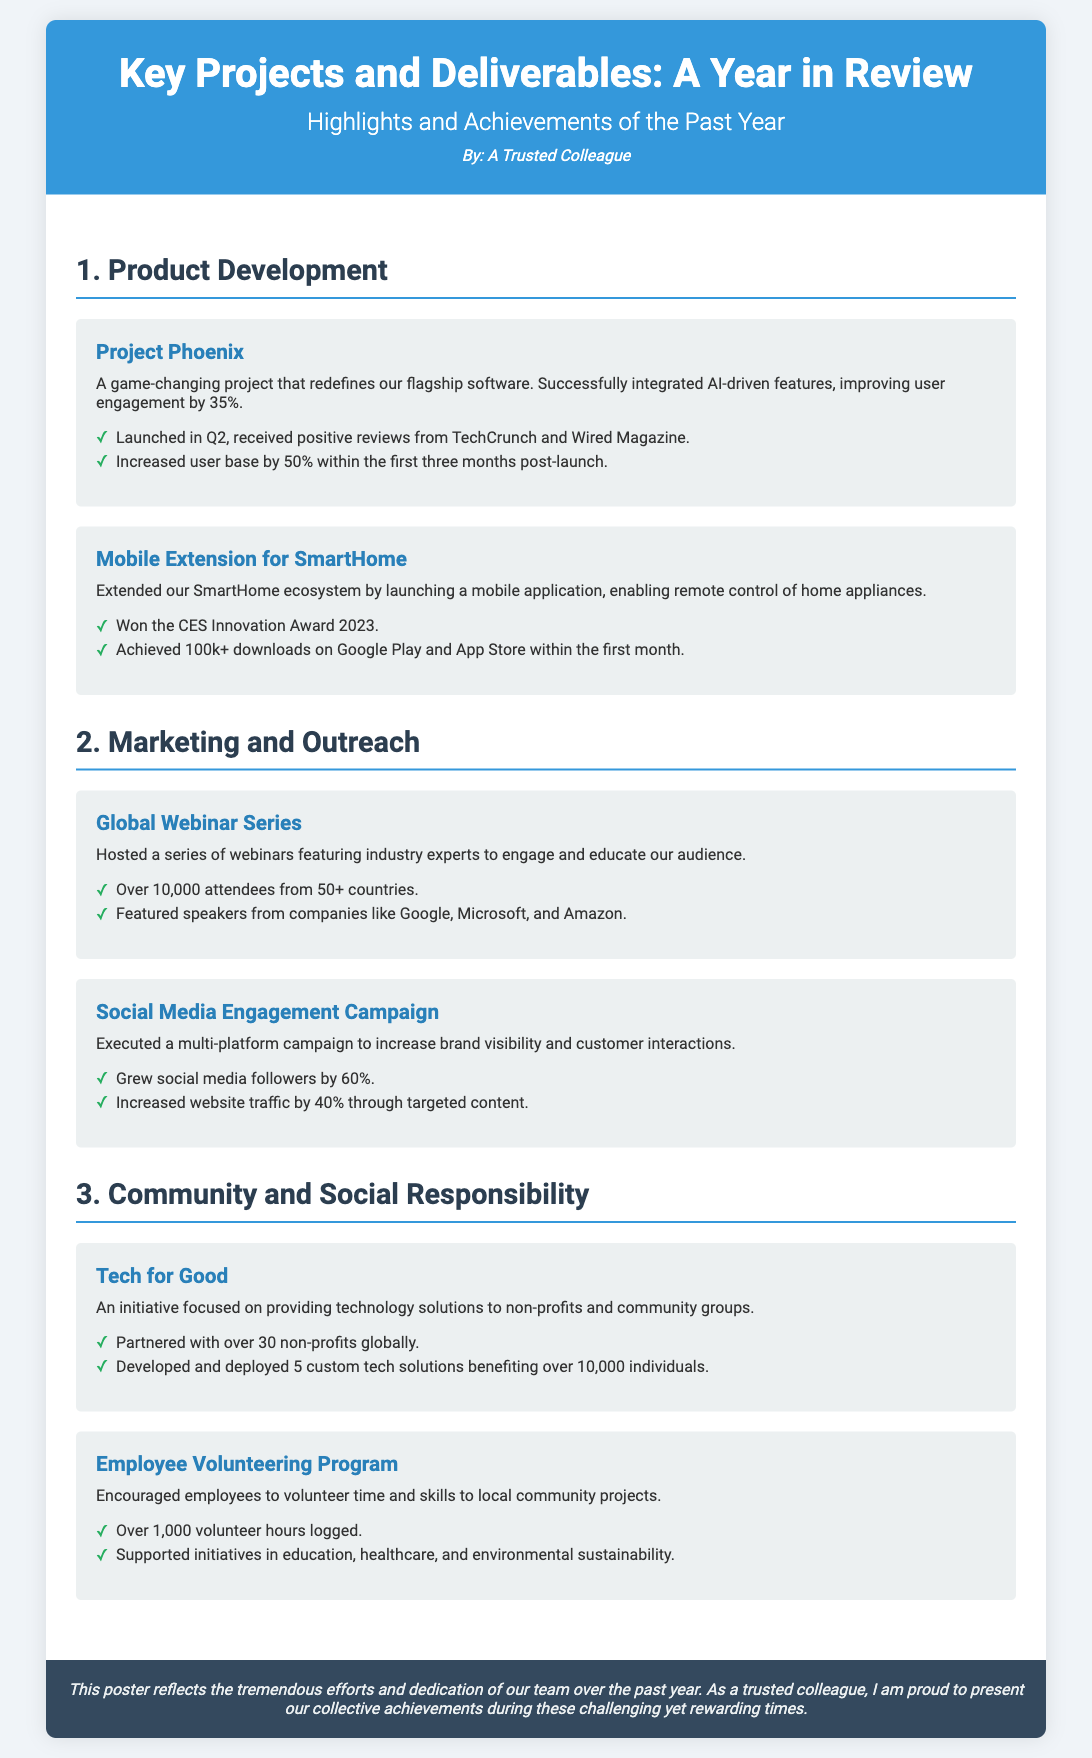what is the name of the first project in Product Development? The first project listed in the Product Development section is called Project Phoenix.
Answer: Project Phoenix how much did user engagement improve due to Project Phoenix? The improvement in user engagement due to Project Phoenix is mentioned as 35%.
Answer: 35% which award did the Mobile Extension for SmartHome win? The Mobile Extension for SmartHome won the CES Innovation Award 2023.
Answer: CES Innovation Award 2023 how many attendees were there in the Global Webinar Series? The Global Webinar Series had over 10,000 attendees reported in the document.
Answer: 10,000 what was the percentage increase in social media followers from the engagement campaign? The Social Media Engagement Campaign saw a growth of 60% in social media followers.
Answer: 60% how many volunteer hours were logged in the Employee Volunteering Program? The document states that over 1,000 volunteer hours were logged.
Answer: 1,000 which two sectors did the Employee Volunteering Program support? The Employee Volunteering Program supported education and healthcare initiatives.
Answer: education, healthcare which organizations had featured speakers in the Global Webinar Series? Featured speakers included organizations like Google, Microsoft, and Amazon in the Global Webinar Series.
Answer: Google, Microsoft, Amazon how many non-profits were partnered with in the Tech for Good initiative? The Tech for Good initiative partnered with over 30 non-profits globally.
Answer: 30 